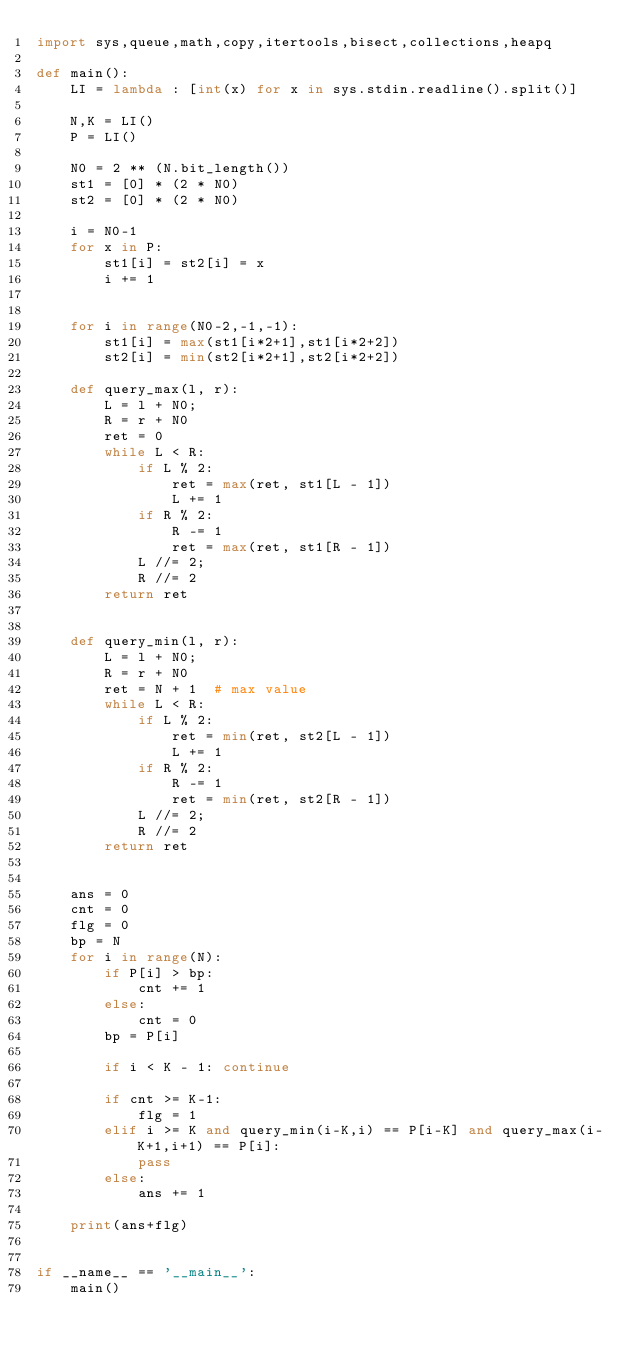Convert code to text. <code><loc_0><loc_0><loc_500><loc_500><_Python_>import sys,queue,math,copy,itertools,bisect,collections,heapq

def main():
    LI = lambda : [int(x) for x in sys.stdin.readline().split()]

    N,K = LI()
    P = LI()

    N0 = 2 ** (N.bit_length())
    st1 = [0] * (2 * N0)
    st2 = [0] * (2 * N0)

    i = N0-1
    for x in P:
        st1[i] = st2[i] = x
        i += 1


    for i in range(N0-2,-1,-1):
        st1[i] = max(st1[i*2+1],st1[i*2+2])
        st2[i] = min(st2[i*2+1],st2[i*2+2])

    def query_max(l, r):
        L = l + N0;
        R = r + N0
        ret = 0
        while L < R:
            if L % 2:
                ret = max(ret, st1[L - 1])
                L += 1
            if R % 2:
                R -= 1
                ret = max(ret, st1[R - 1])
            L //= 2;
            R //= 2
        return ret


    def query_min(l, r):
        L = l + N0;
        R = r + N0
        ret = N + 1  # max value
        while L < R:
            if L % 2:
                ret = min(ret, st2[L - 1])
                L += 1
            if R % 2:
                R -= 1
                ret = min(ret, st2[R - 1])
            L //= 2;
            R //= 2
        return ret


    ans = 0
    cnt = 0
    flg = 0
    bp = N
    for i in range(N):
        if P[i] > bp:
            cnt += 1
        else:
            cnt = 0
        bp = P[i]

        if i < K - 1: continue

        if cnt >= K-1:
            flg = 1
        elif i >= K and query_min(i-K,i) == P[i-K] and query_max(i-K+1,i+1) == P[i]:
            pass
        else:
            ans += 1

    print(ans+flg)


if __name__ == '__main__':
    main()</code> 